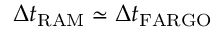Convert formula to latex. <formula><loc_0><loc_0><loc_500><loc_500>\Delta t _ { R A M } \simeq \Delta t _ { F A R G O }</formula> 